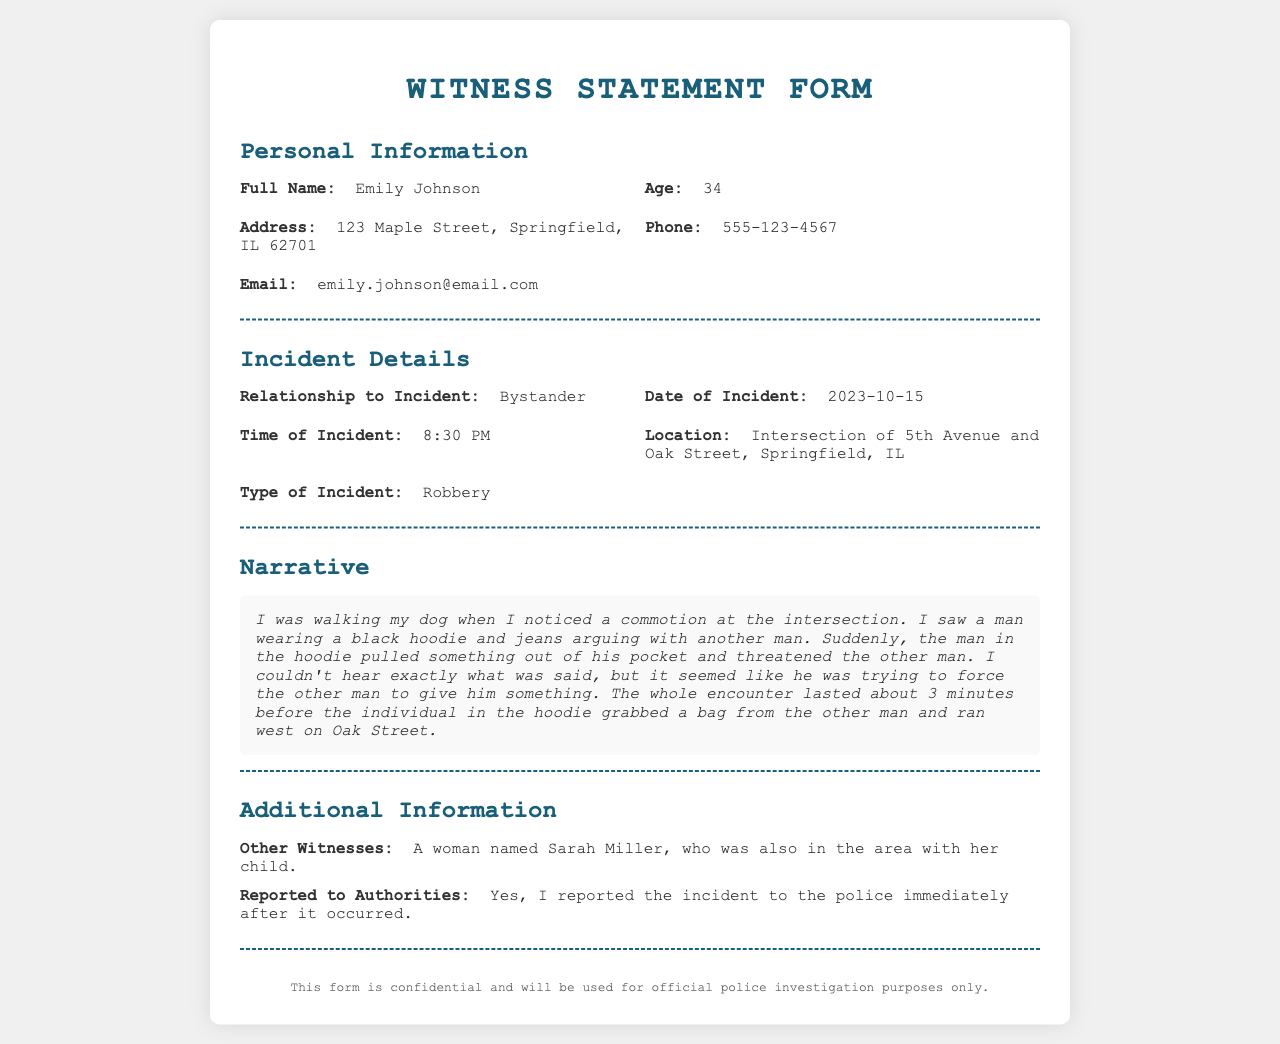What is the full name of the witness? The witness's full name is provided in the personal information section of the document.
Answer: Emily Johnson What is the age of the witness? The age of the witness is listed in the personal information section.
Answer: 34 What is the type of incident reported? The type of incident is mentioned in the incident details section of the document.
Answer: Robbery What time did the incident occur? The time of the incident is specified in the incident details section.
Answer: 8:30 PM Who reported the incident to authorities? The document states that the witness reported the incident, identifying her at the top.
Answer: Emily Johnson What did the man in the hoodie take from the other man? The narrative describes what occurred during the incident, specifically mentioning what was taken.
Answer: A bag Where did the robbery take place? The location is indicated in the incident details section of the document.
Answer: Intersection of 5th Avenue and Oak Street How long did the encounter last? The witness provided a duration for the encounter in her narrative.
Answer: About 3 minutes Who is another witness mentioned? The additional information section provides names of other witnesses who were present.
Answer: Sarah Miller 